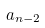Convert formula to latex. <formula><loc_0><loc_0><loc_500><loc_500>a _ { n - 2 }</formula> 